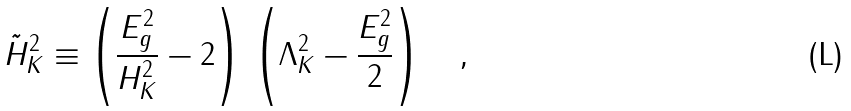Convert formula to latex. <formula><loc_0><loc_0><loc_500><loc_500>\tilde { H } _ { K } ^ { 2 } \equiv \left ( \frac { E _ { g } ^ { 2 } } { H _ { K } ^ { 2 } } - 2 \right ) \, \left ( \Lambda _ { K } ^ { 2 } - \frac { E _ { g } ^ { 2 } } { 2 } \right ) \quad ,</formula> 